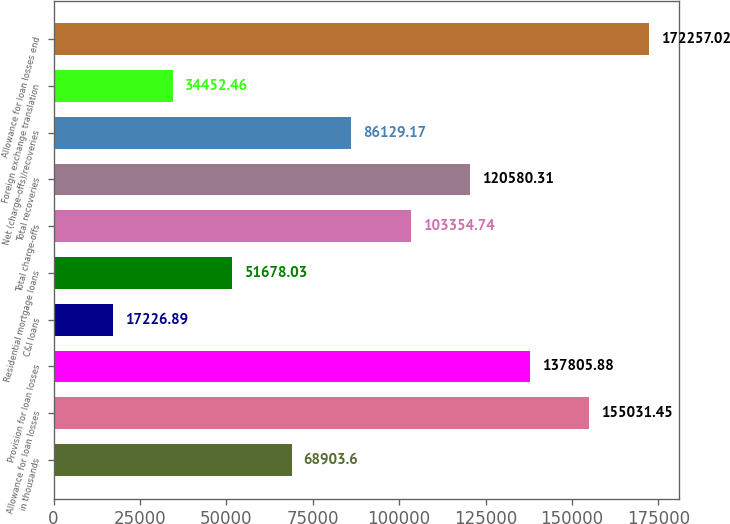Convert chart to OTSL. <chart><loc_0><loc_0><loc_500><loc_500><bar_chart><fcel>in thousands<fcel>Allowance for loan losses<fcel>Provision for loan losses<fcel>C&I loans<fcel>Residential mortgage loans<fcel>Total charge-offs<fcel>Total recoveries<fcel>Net (charge-offs)/recoveries<fcel>Foreign exchange translation<fcel>Allowance for loan losses end<nl><fcel>68903.6<fcel>155031<fcel>137806<fcel>17226.9<fcel>51678<fcel>103355<fcel>120580<fcel>86129.2<fcel>34452.5<fcel>172257<nl></chart> 